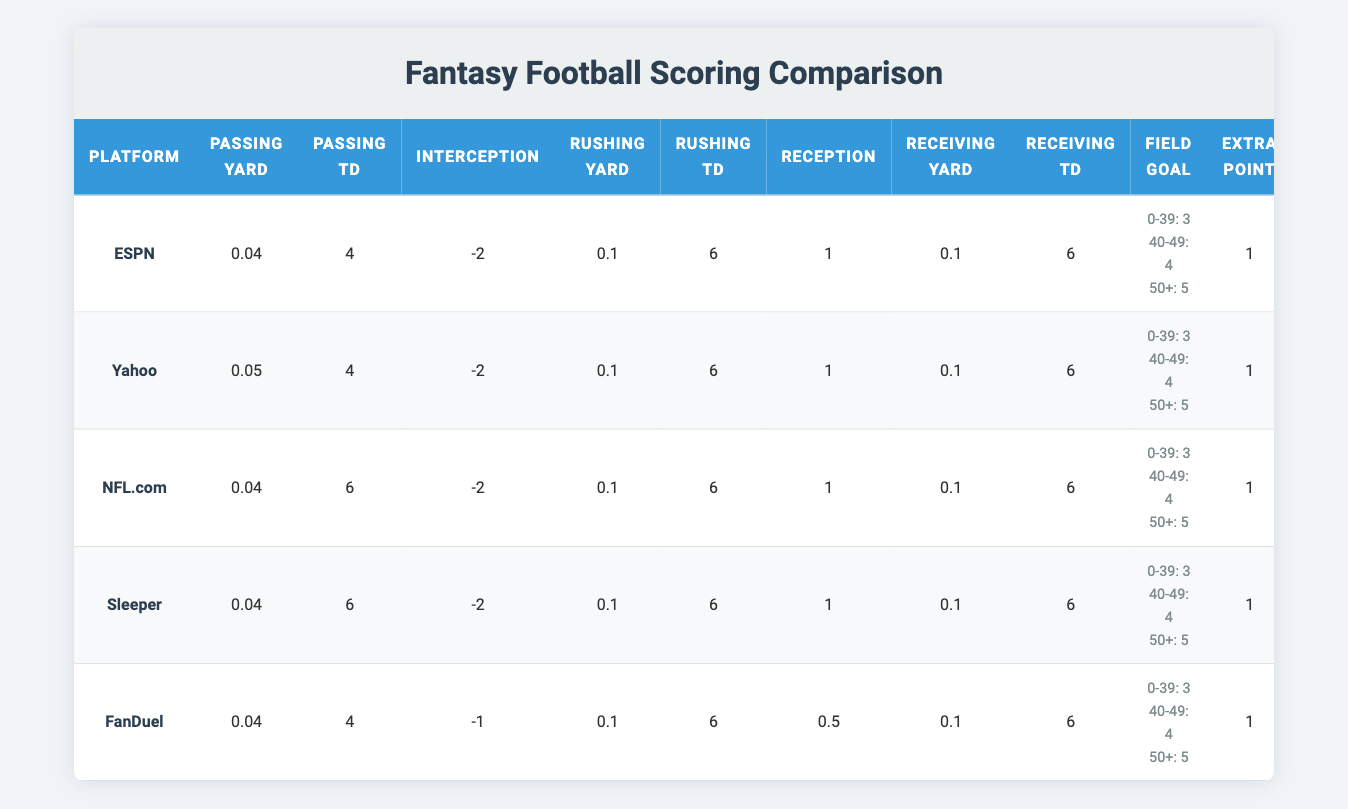What is the scoring for passing yards on ESPN? Referring to the ESPN row in the table, the value for passing yards is 0.04.
Answer: 0.04 Which platform awards the most points for a passing touchdown? Looking at the passing touchdown column, NFL.com and Sleeper award 6 points each for a passing touchdown, which is higher than the 4 points given by ESPN, Yahoo, and FanDuel.
Answer: NFL.com and Sleeper What is the highest penalty for interceptions? In the table, both ESPN, Yahoo, and NFL.com have a penalty of -2 points for interceptions, while FanDuel has a penalty of -1 point. Thus, -2 is the highest penalty for interceptions.
Answer: -2 How many total points would a player earn for achieving 300 passing yards and 2 passing touchdowns on Yahoo? Using the scoring values, 300 passing yards at 0.05 points per yard would yield 15 points (300 * 0.05). For 2 passing touchdowns at 4 points each, that adds 8 points (2 * 4). Summing them gives a total of 23 points (15 + 8 = 23).
Answer: 23 Is it true that FanDuel gives fewer points for receptions compared to the other platforms? Checking the reception values, FanDuel awards 0.5 points, whereas all other platforms (ESPN, Yahoo, NFL.com, and Sleeper) award 1 point each for receptions. Therefore, it is true that FanDuel gives fewer points for receptions.
Answer: Yes What is the average score awarded for receiving touchdowns across all platforms? The scores for receiving touchdowns are 6 for ESPN, Yahoo, NFL.com, Sleeper, and 6 for FanDuel. Adding them (6 + 6 + 6 + 6 + 6) = 30 and dividing by the number of platforms (5) gives an average of 6 (30/5 = 6).
Answer: 6 How does the field goal scoring vary across the platforms? All platforms provide the same scoring for field goals at varying distances, with 3 points for 0-39 yards, 4 points for 40-49 yards, and 5 points for 50+ yards. Thus, there is no variation in field goal scoring across platforms.
Answer: No variation If a player scores a touchdown and kicks an extra point on ESPN, what would be their total score from these actions? For ESPN, a touchdown is worth 6 points and an extra point is worth 1 point. Thus, the total score from these actions would be 7 points (6 + 1 = 7).
Answer: 7 Which platform has the highest score for a passing touchdown with no penalties from interceptions? NFL.com and Sleeper provide the highest score of 6 points for passing touchdowns, maintaining the same penalty structure for interceptions as the rest. Both platform scores are equal.
Answer: NFL.com and Sleeper 